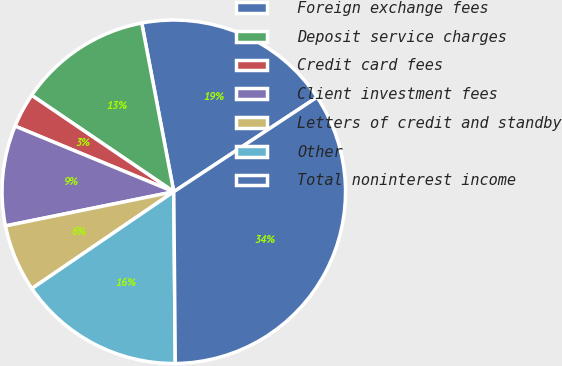Convert chart. <chart><loc_0><loc_0><loc_500><loc_500><pie_chart><fcel>Foreign exchange fees<fcel>Deposit service charges<fcel>Credit card fees<fcel>Client investment fees<fcel>Letters of credit and standby<fcel>Other<fcel>Total noninterest income<nl><fcel>18.7%<fcel>12.52%<fcel>3.25%<fcel>9.43%<fcel>6.34%<fcel>15.61%<fcel>34.14%<nl></chart> 